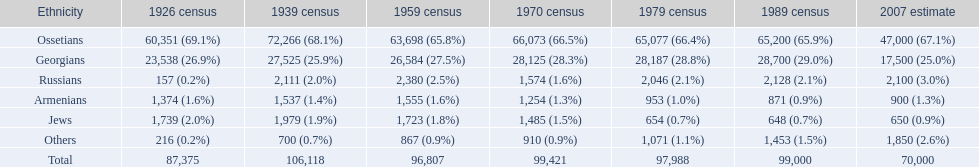Can you give me this table as a dict? {'header': ['Ethnicity', '1926 census', '1939 census', '1959 census', '1970 census', '1979 census', '1989 census', '2007 estimate'], 'rows': [['Ossetians', '60,351 (69.1%)', '72,266 (68.1%)', '63,698 (65.8%)', '66,073 (66.5%)', '65,077 (66.4%)', '65,200 (65.9%)', '47,000 (67.1%)'], ['Georgians', '23,538 (26.9%)', '27,525 (25.9%)', '26,584 (27.5%)', '28,125 (28.3%)', '28,187 (28.8%)', '28,700 (29.0%)', '17,500 (25.0%)'], ['Russians', '157 (0.2%)', '2,111 (2.0%)', '2,380 (2.5%)', '1,574 (1.6%)', '2,046 (2.1%)', '2,128 (2.1%)', '2,100 (3.0%)'], ['Armenians', '1,374 (1.6%)', '1,537 (1.4%)', '1,555 (1.6%)', '1,254 (1.3%)', '953 (1.0%)', '871 (0.9%)', '900 (1.3%)'], ['Jews', '1,739 (2.0%)', '1,979 (1.9%)', '1,723 (1.8%)', '1,485 (1.5%)', '654 (0.7%)', '648 (0.7%)', '650 (0.9%)'], ['Others', '216 (0.2%)', '700 (0.7%)', '867 (0.9%)', '910 (0.9%)', '1,071 (1.1%)', '1,453 (1.5%)', '1,850 (2.6%)'], ['Total', '87,375', '106,118', '96,807', '99,421', '97,988', '99,000', '70,000']]} Based on the list, who is prior to the russians? Georgians. 